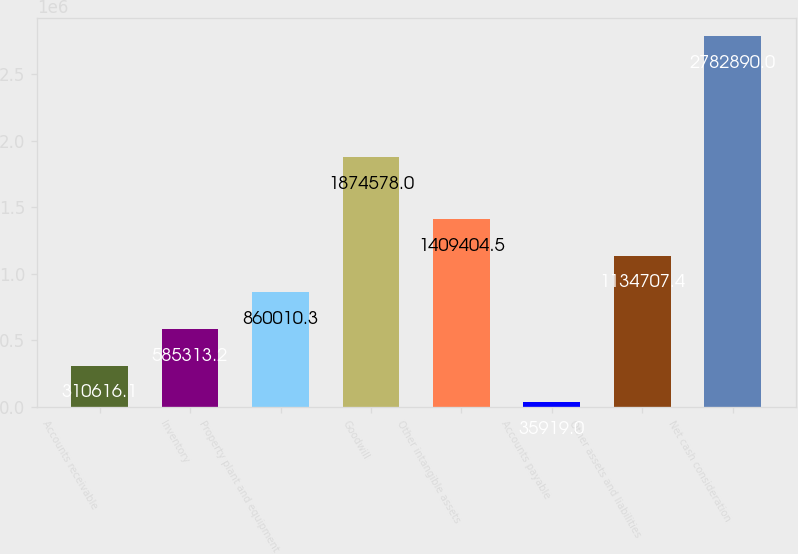Convert chart to OTSL. <chart><loc_0><loc_0><loc_500><loc_500><bar_chart><fcel>Accounts receivable<fcel>Inventory<fcel>Property plant and equipment<fcel>Goodwill<fcel>Other intangible assets<fcel>Accounts payable<fcel>Other assets and liabilities<fcel>Net cash consideration<nl><fcel>310616<fcel>585313<fcel>860010<fcel>1.87458e+06<fcel>1.4094e+06<fcel>35919<fcel>1.13471e+06<fcel>2.78289e+06<nl></chart> 